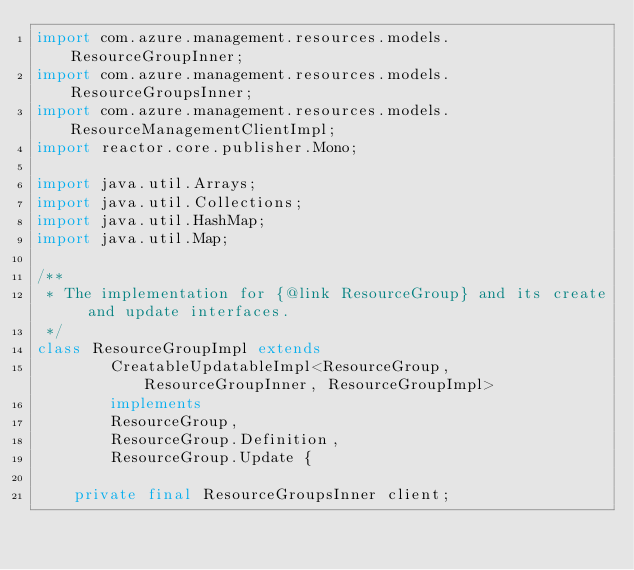<code> <loc_0><loc_0><loc_500><loc_500><_Java_>import com.azure.management.resources.models.ResourceGroupInner;
import com.azure.management.resources.models.ResourceGroupsInner;
import com.azure.management.resources.models.ResourceManagementClientImpl;
import reactor.core.publisher.Mono;

import java.util.Arrays;
import java.util.Collections;
import java.util.HashMap;
import java.util.Map;

/**
 * The implementation for {@link ResourceGroup} and its create and update interfaces.
 */
class ResourceGroupImpl extends
        CreatableUpdatableImpl<ResourceGroup, ResourceGroupInner, ResourceGroupImpl>
        implements
        ResourceGroup,
        ResourceGroup.Definition,
        ResourceGroup.Update {

    private final ResourceGroupsInner client;
</code> 